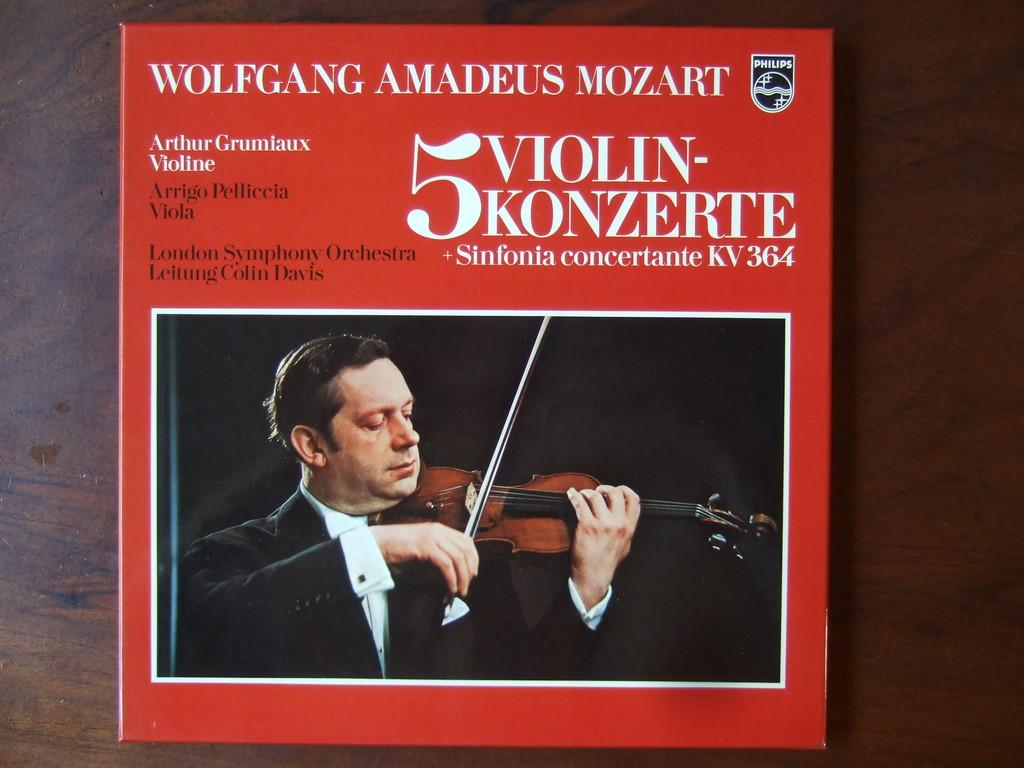What is the main subject of the image? The main subject of the image is a man. What is the man doing in the image? The man is playing the violin in the image. Where is the image located? The image is the cover page of a book. Is there any text present in the image? Yes, there is text at the top of the image. Can you see any wounds on the man's hands while he is playing the violin? There is no indication of any wounds on the man's hands in the image. Is there a goat present in the image? No, there is no goat present in the image. 